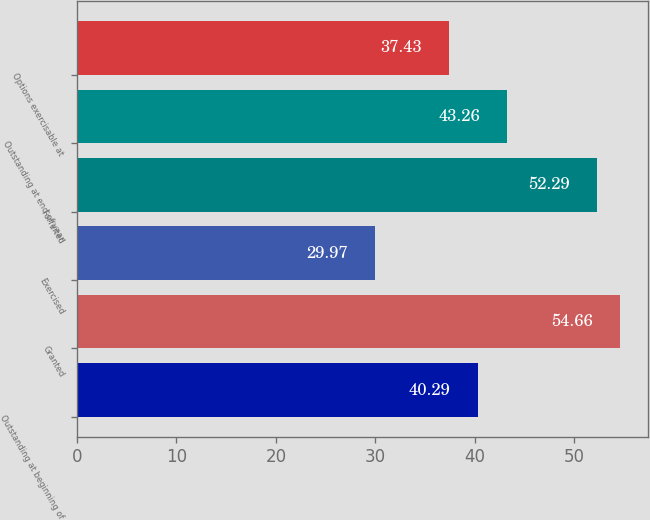Convert chart to OTSL. <chart><loc_0><loc_0><loc_500><loc_500><bar_chart><fcel>Outstanding at beginning of<fcel>Granted<fcel>Exercised<fcel>Forfeited<fcel>Outstanding at end of year<fcel>Options exercisable at<nl><fcel>40.29<fcel>54.66<fcel>29.97<fcel>52.29<fcel>43.26<fcel>37.43<nl></chart> 